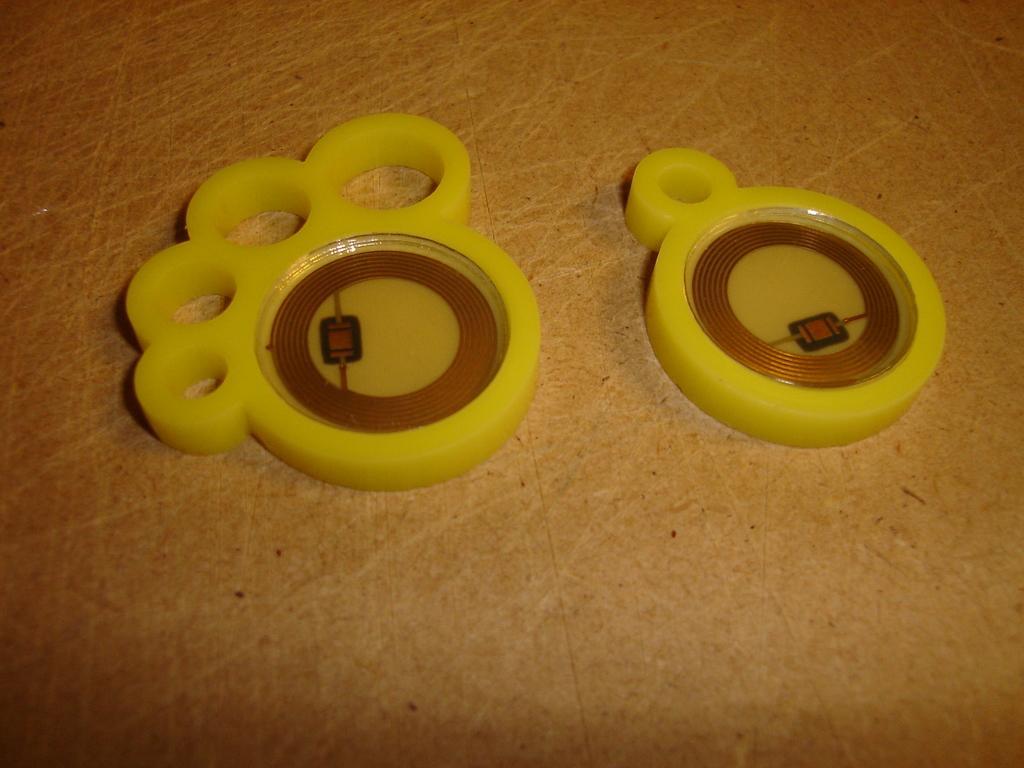Can you describe this image briefly? In this picture there are two objects, on the floor, they are yellow in color. 